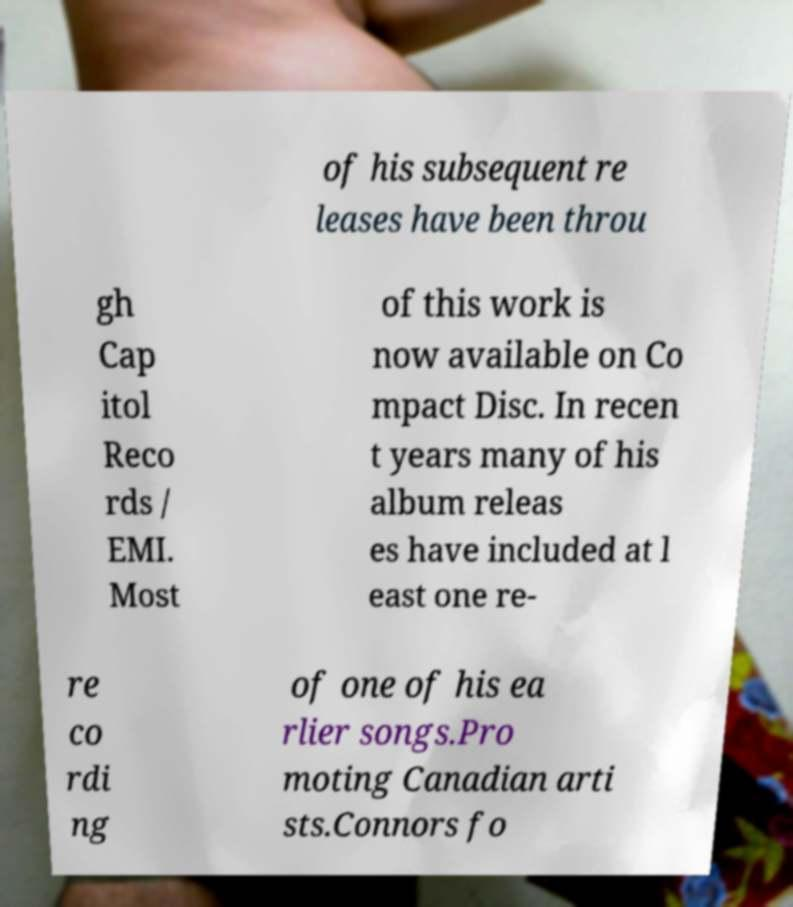Please read and relay the text visible in this image. What does it say? of his subsequent re leases have been throu gh Cap itol Reco rds / EMI. Most of this work is now available on Co mpact Disc. In recen t years many of his album releas es have included at l east one re- re co rdi ng of one of his ea rlier songs.Pro moting Canadian arti sts.Connors fo 